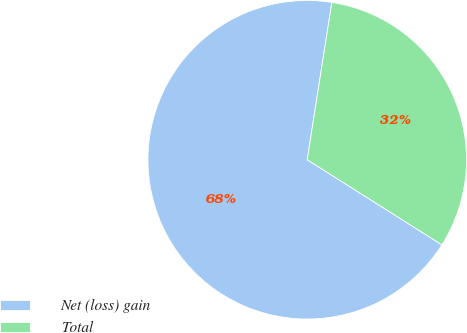Convert chart to OTSL. <chart><loc_0><loc_0><loc_500><loc_500><pie_chart><fcel>Net (loss) gain<fcel>Total<nl><fcel>68.5%<fcel>31.5%<nl></chart> 